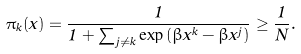<formula> <loc_0><loc_0><loc_500><loc_500>\pi _ { k } ( x ) = \frac { 1 } { 1 + \sum _ { j \neq k } \exp \left ( \beta x ^ { k } - \beta x ^ { j } \right ) } \geq \frac { 1 } { N } .</formula> 